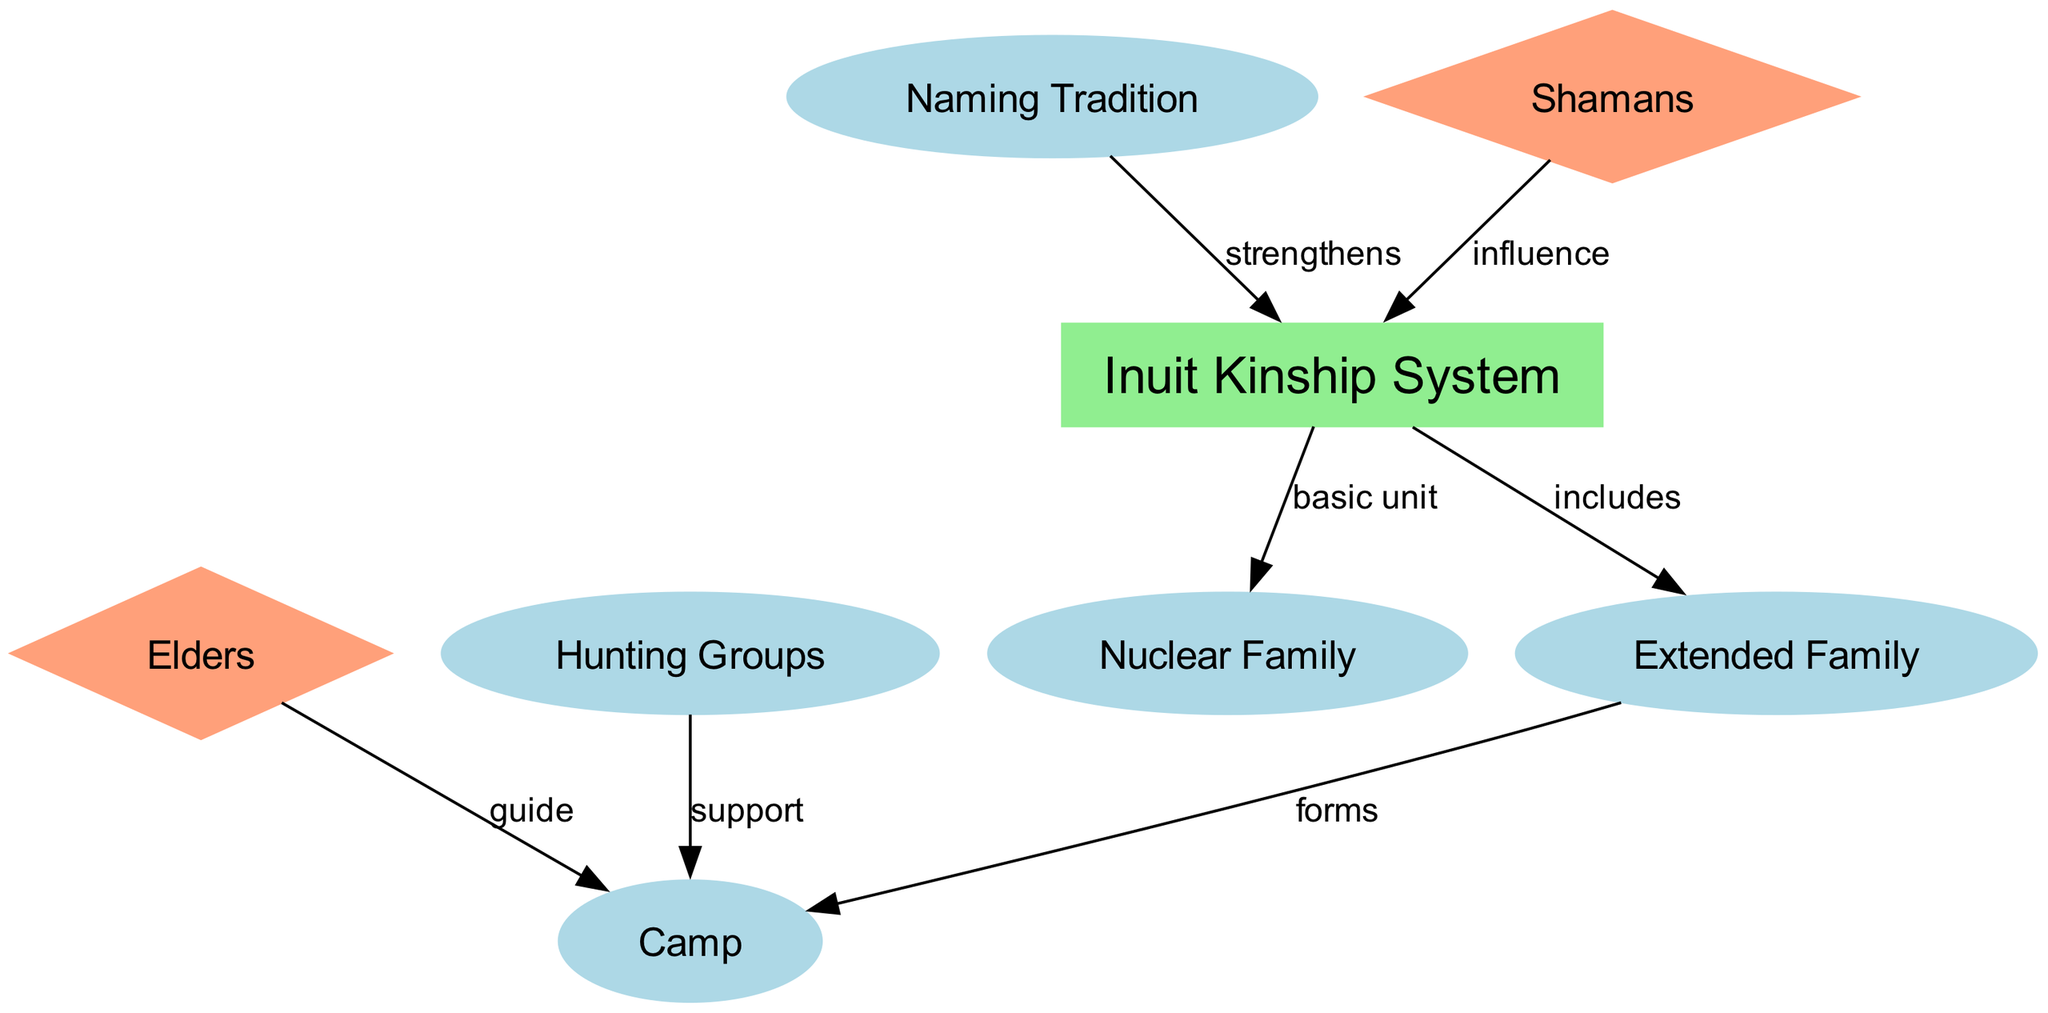What is the basic unit of the Inuit kinship system? The concept map indicates that the "Nuclear Family" is identified as the "basic unit" of the Inuit kinship system, as shown by the directed edge connecting "inuit_kinship" to "nuclear_family".
Answer: Nuclear Family How many main nodes are present in the diagram? By counting the nodes listed, there are a total of eight nodes, including "inuit_kinship", "nuclear_family", "extended_family", "camp", "elders", "naming_tradition", "hunting_groups", and "shamans".
Answer: Eight Which node guides the camp? The diagram shows a directed edge from "elders" to "camp", indicating that elders play the role of guiding the camp, as specified in the relationship label.
Answer: Elders What does the naming tradition do in relation to the Inuit kinship? According to the edge connecting "naming_tradition" to "inuit_kinship", the labeling indicates that it "strengthens" the kinship system, highlighting the importance of naming practices in Inuit culture.
Answer: Strengthens What forms the camp within the extended family? The diagram reveals that the "extended family" connects to the "camp" node with a label that states it "forms" the camp, indicating the role of extended families in creating camps.
Answer: Forms How do hunters contribute to the camp? An edge from "hunting_groups" to "camp" suggests that hunting groups "support" the camp, emphasizing the importance of hunting collaboration for communal living.
Answer: Support In what way do shamans influence the Inuit kinship system? The edge from "shamans" to "inuit_kinship" reveals that they "influence" the kinship system, highlighting their role in shaping social relationships and cultural practices.
Answer: Influence What type of family includes the nuclear family in the Inuit kinship system? The diagram shows an edge connecting "inuit_kinship" to "extended_family" with the label "includes", which reveals that the extended family encompasses the nuclear family as part of its structure.
Answer: Extended Family 